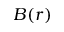Convert formula to latex. <formula><loc_0><loc_0><loc_500><loc_500>B ( r )</formula> 